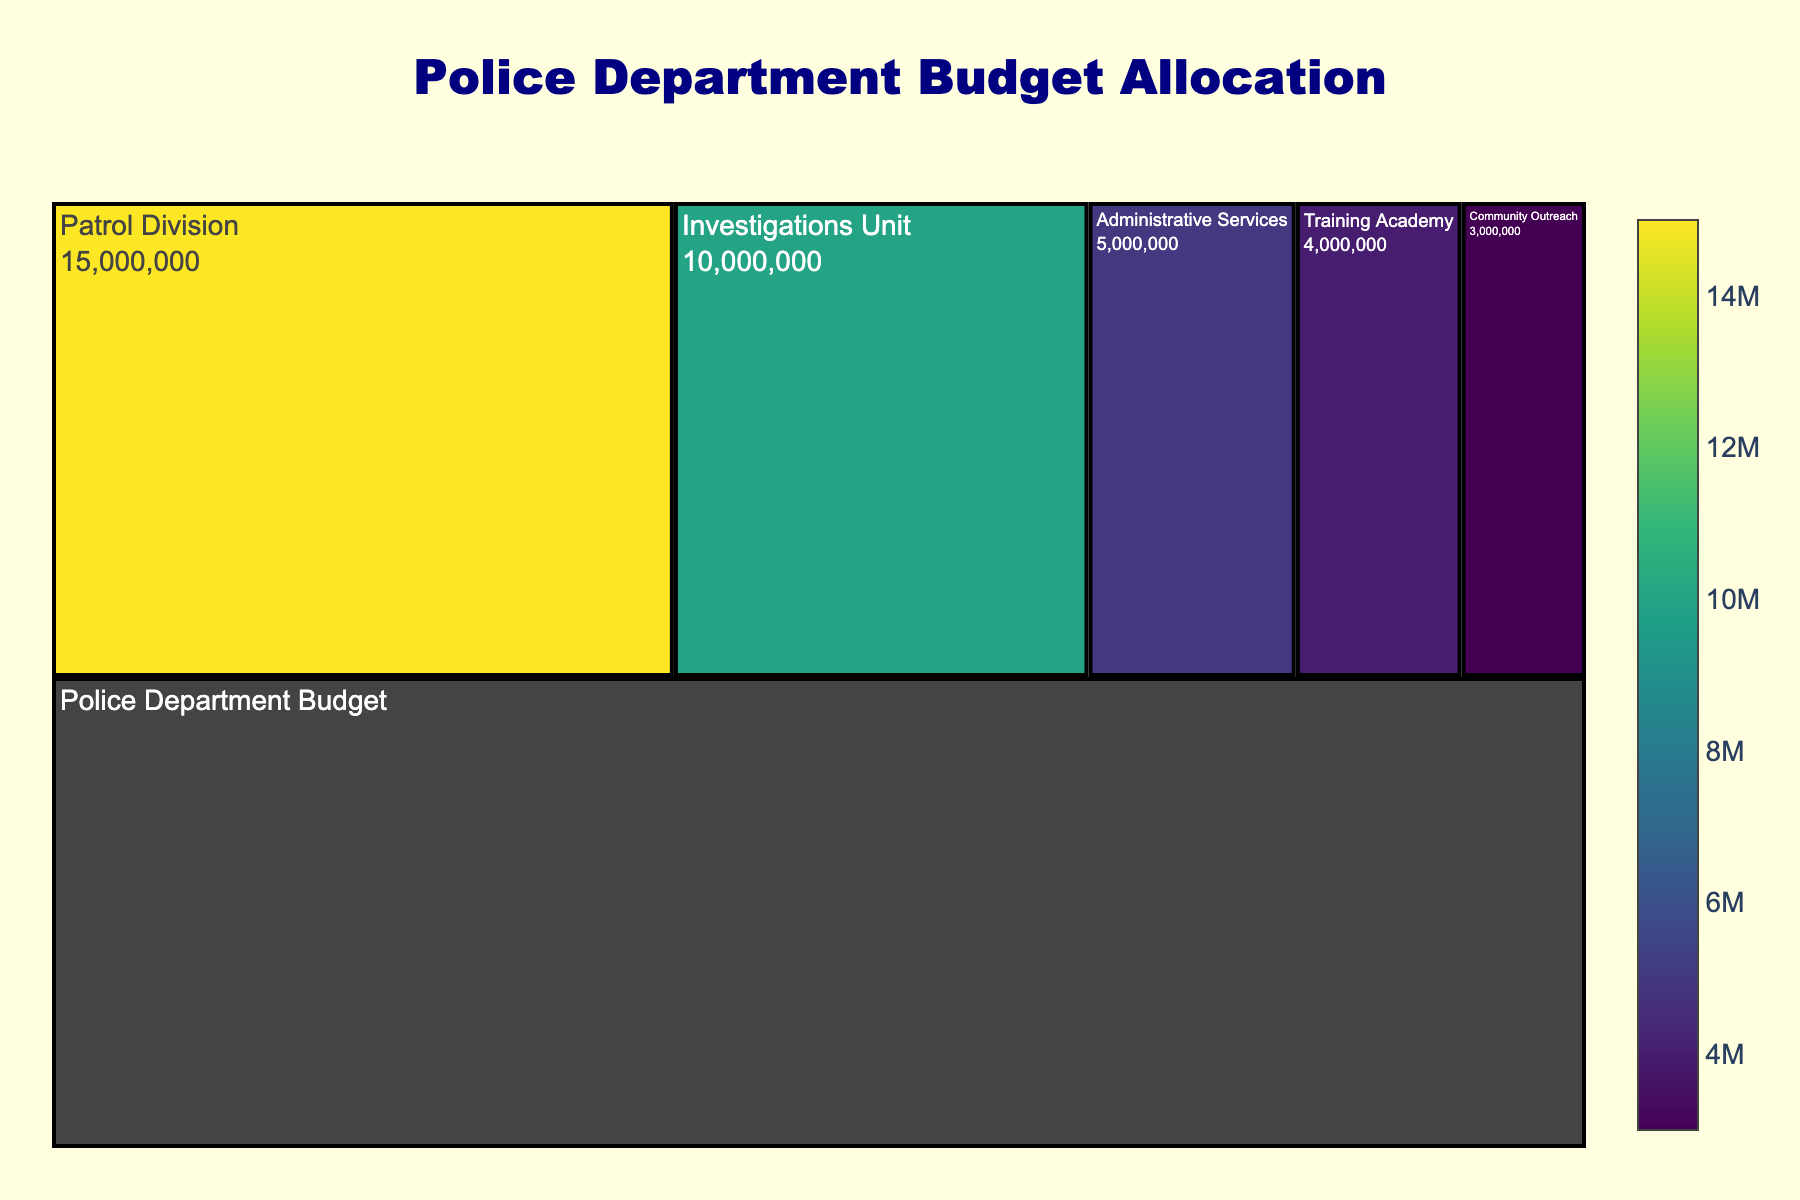What is the total budget allocated to the Patrol Division? The chart shows the values associated with each subcategory of the Police Department Budget. The Patrol Division has a budget allocation explicitly mentioned.
Answer: $15,000,000 What is the title of the figure? The title is located at the top of the figure, centered and in larger, bold font.
Answer: Police Department Budget Allocation How much more budget is allocated to the Patrol Division compared to the Training Academy? The Patrol Division has $15,000,000, and the Training Academy has $4,000,000. Subtract the Training Academy's budget from the Patrol Division's budget.
Answer: $11,000,000 What is the combined budget for Administrative Services and Community Outreach? Find the values for Administrative Services ($5,000,000) and Community Outreach ($3,000,000) and add them together.
Answer: $8,000,000 Which unit has the smallest budget allocation? Compare the budget values of all the units. The unit with the smallest numerical value has the smallest allocation.
Answer: Community Outreach By how much does the Investigations Unit outspend the Administrative Services? The Investigations Unit has $10,000,000 and Administrative Services have $5,000,000. Subtract the budget of Administrative Services from the Investigations Unit.
Answer: $5,000,000 What percentage of the total budget is allocated to the Community Outreach unit? First, find the total budget by adding all subcategory values (15,000,000 + 10,000,000 + 5,000,000 + 3,000,000 + 4,000,000 = $37,000,000). Then, calculate the percentage: (3,000,000 / 37,000,000) * 100.
Answer: Approximately 8.11% How is the tilt of the icicle branches oriented? The figure's description explains the tiling orientation of the branches.
Answer: Vertically oriented, flipped on the y-axis Which unit has the second-highest budget allocation? Compare the budget values of each unit to determine the second-highest value. The Patrol Division has the highest, and the Investigations Unit is next with $10,000,000.
Answer: Investigations Unit 